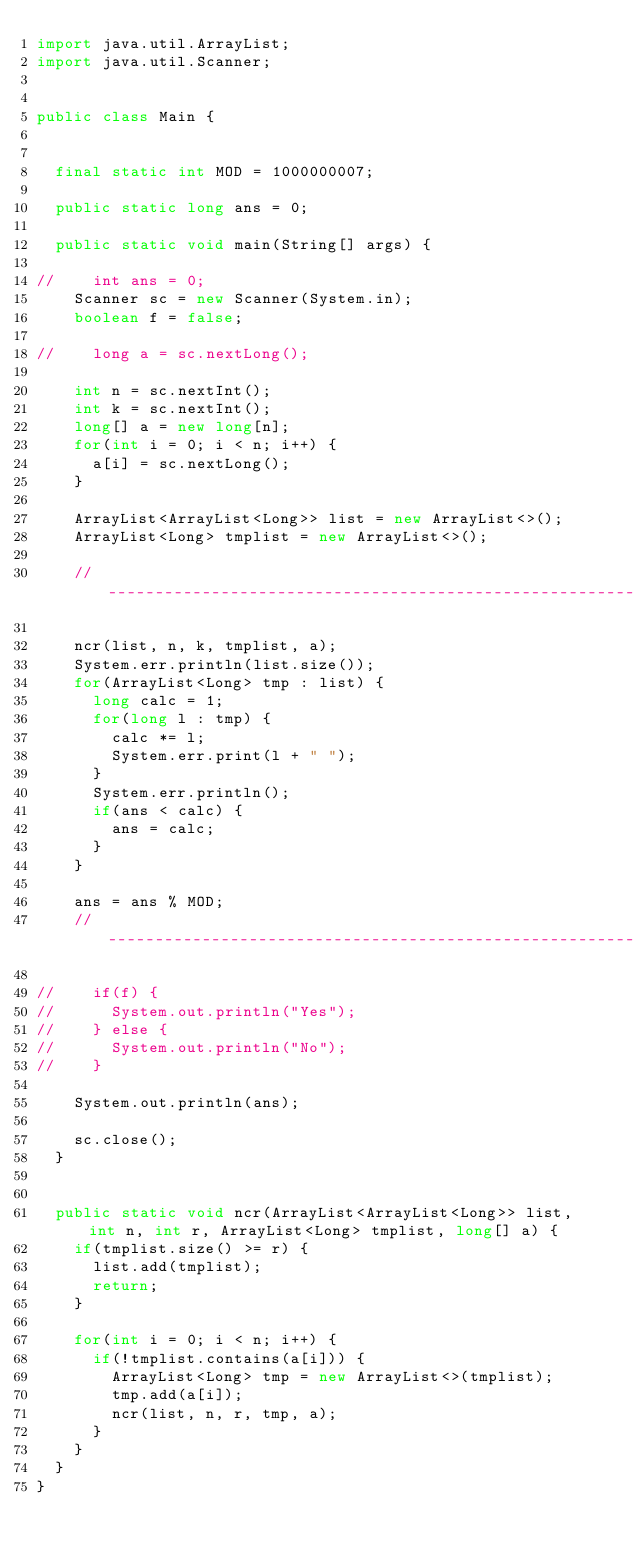<code> <loc_0><loc_0><loc_500><loc_500><_Java_>import java.util.ArrayList;
import java.util.Scanner;


public class Main {


	final static int MOD = 1000000007;

	public static long ans = 0;

	public static void main(String[] args) {

//		int ans = 0;
		Scanner sc = new Scanner(System.in);
		boolean f = false;

//		long a = sc.nextLong();

		int n = sc.nextInt();
		int k = sc.nextInt();
		long[] a = new long[n];
		for(int i = 0; i < n; i++) {
			a[i] = sc.nextLong();
		}

		ArrayList<ArrayList<Long>> list = new ArrayList<>();
		ArrayList<Long> tmplist = new ArrayList<>();

		//-------------------------------------------------------------------------------------

		ncr(list, n, k, tmplist, a);
		System.err.println(list.size());
		for(ArrayList<Long> tmp : list) {
			long calc = 1;
			for(long l : tmp) {
				calc *= l;
				System.err.print(l + " ");
			}
			System.err.println();
			if(ans < calc) {
				ans = calc;
			}
		}

		ans = ans % MOD;
		//-------------------------------------------------------------------------------------

//		if(f) {
//			System.out.println("Yes");
//		} else {
//			System.out.println("No");
//		}

		System.out.println(ans);

		sc.close();
	}


	public static void ncr(ArrayList<ArrayList<Long>> list, int n, int r, ArrayList<Long> tmplist, long[] a) {
		if(tmplist.size() >= r) {
			list.add(tmplist);
			return;
		}

		for(int i = 0; i < n; i++) {
			if(!tmplist.contains(a[i])) {
				ArrayList<Long> tmp = new ArrayList<>(tmplist);
				tmp.add(a[i]);
				ncr(list, n, r, tmp, a);
			}
		}
	}
}</code> 